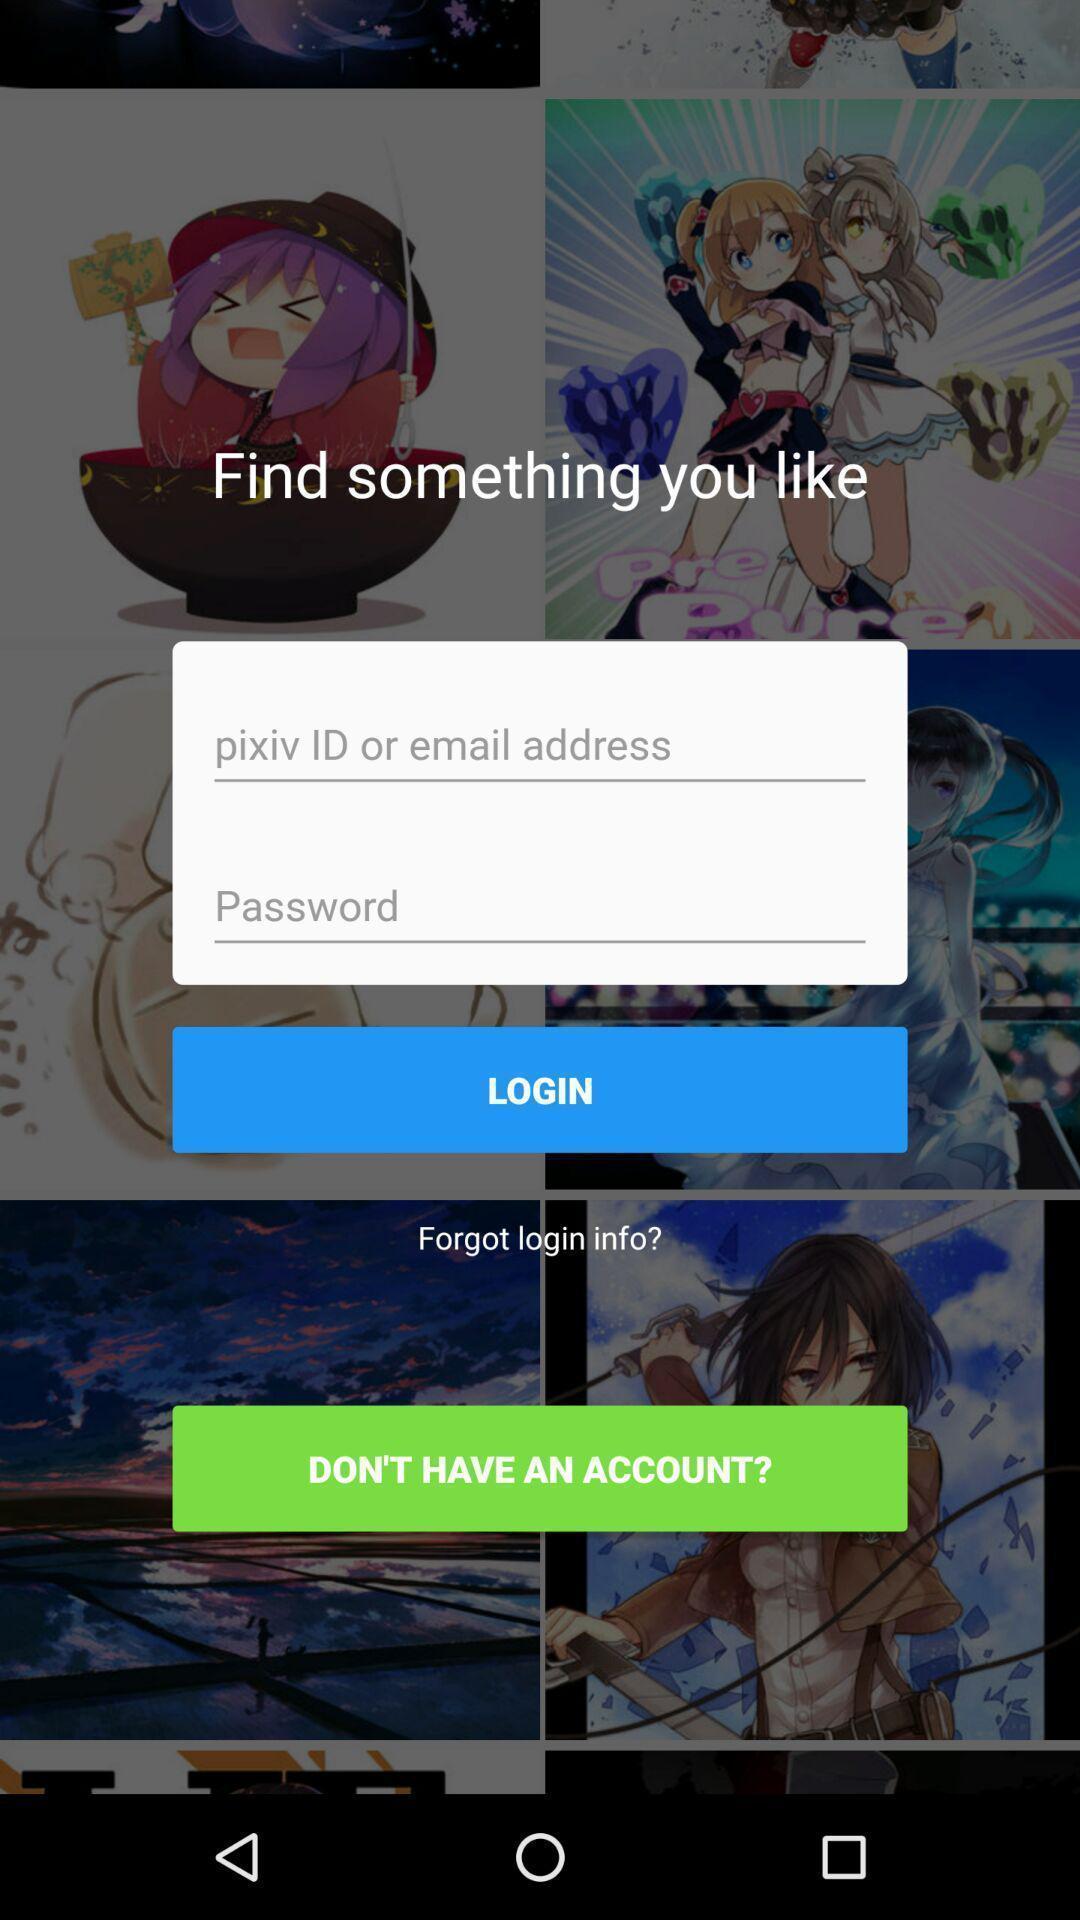Please provide a description for this image. Screen displaying the login page. 